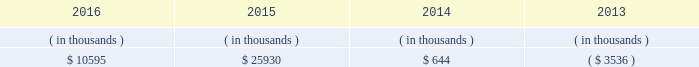Entergy mississippi , inc .
Management 2019s financial discussion and analysis entergy mississippi 2019s receivables from or ( payables to ) the money pool were as follows as of december 31 for each of the following years. .
See note 4 to the financial statements for a description of the money pool .
Entergy mississippi has four separate credit facilities in the aggregate amount of $ 102.5 million scheduled to expire may 2017 .
No borrowings were outstanding under the credit facilities as of december 31 , 2016 .
In addition , entergy mississippi is a party to an uncommitted letter of credit facility as a means to post collateral to support its obligations under miso .
As of december 31 , 2016 , a $ 7.1 million letter of credit was outstanding under entergy mississippi 2019s uncommitted letter of credit facility .
See note 4 to the financial statements for additional discussion of the credit facilities .
Entergy mississippi obtained authorizations from the ferc through october 2017 for short-term borrowings not to exceed an aggregate amount of $ 175 million at any time outstanding and long-term borrowings and security issuances .
See note 4 to the financial statements for further discussion of entergy mississippi 2019s short-term borrowing limits .
State and local rate regulation and fuel-cost recovery the rates that entergy mississippi charges for electricity significantly influence its financial position , results of operations , and liquidity .
Entergy mississippi is regulated and the rates charged to its customers are determined in regulatory proceedings .
A governmental agency , the mpsc , is primarily responsible for approval of the rates charged to customers .
Formula rate plan in june 2014 , entergy mississippi filed its first general rate case before the mpsc in almost 12 years .
The rate filing laid out entergy mississippi 2019s plans for improving reliability , modernizing the grid , maintaining its workforce , stabilizing rates , utilizing new technologies , and attracting new industry to its service territory .
Entergy mississippi requested a net increase in revenue of $ 49 million for bills rendered during calendar year 2015 , including $ 30 million resulting from new depreciation rates to update the estimated service life of assets .
In addition , the filing proposed , among other things : 1 ) realigning cost recovery of the attala and hinds power plant acquisitions from the power management rider to base rates ; 2 ) including certain miso-related revenues and expenses in the power management rider ; 3 ) power management rider changes that reflect the changes in costs and revenues that will accompany entergy mississippi 2019s withdrawal from participation in the system agreement ; and 4 ) a formula rate plan forward test year to allow for known changes in expenses and revenues for the rate effective period .
Entergy mississippi proposed maintaining the current authorized return on common equity of 10.59% ( 10.59 % ) .
In october 2014 , entergy mississippi and the mississippi public utilities staff entered into and filed joint stipulations that addressed the majority of issues in the proceeding .
The stipulations provided for : 2022 an approximate $ 16 million net increase in revenues , which reflected an agreed upon 10.07% ( 10.07 % ) return on common equity ; 2022 revision of entergy mississippi 2019s formula rate plan by providing entergy mississippi with the ability to reflect known and measurable changes to historical rate base and certain expense amounts ; resolving uncertainty around and obviating the need for an additional rate filing in connection with entergy mississippi 2019s withdrawal from participation in the system agreement ; updating depreciation rates ; and moving costs associated with the attala and hinds generating plants from the power management rider to base rates; .
What is the net change in entergy mississippi 2019s receivables from the money pool from 2014 to 2015? 
Computations: (25930 - 644)
Answer: 25286.0. 